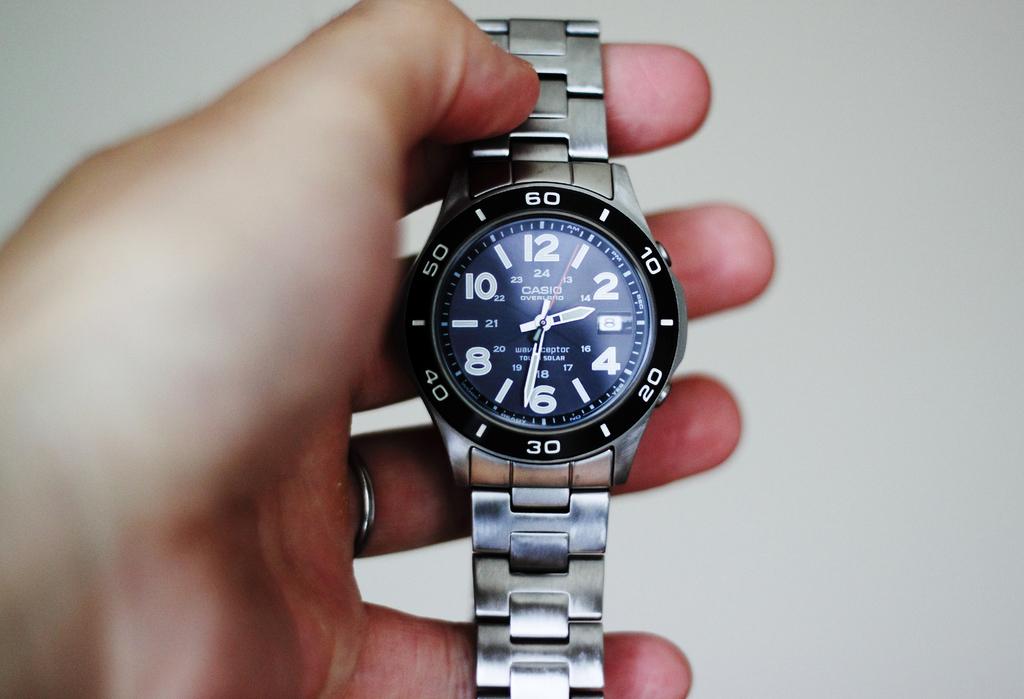What's the number at the top?
Keep it short and to the point. 60. What's the number at the bottom?
Offer a terse response. 30. 